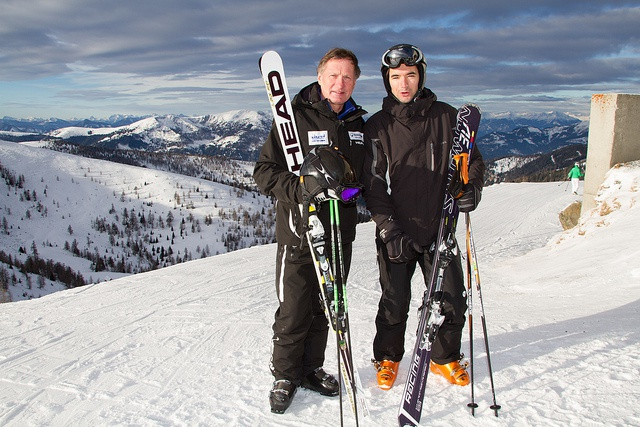Describe the objects in this image and their specific colors. I can see people in darkgray, black, lightgray, and gray tones, people in darkgray, black, and gray tones, skis in darkgray, black, gray, and lightgray tones, skis in darkgray, white, black, and gray tones, and people in darkgray, white, lightgreen, green, and gray tones in this image. 